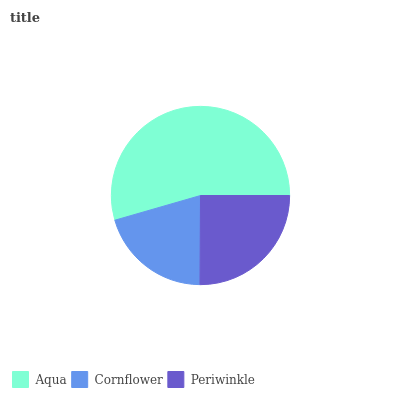Is Cornflower the minimum?
Answer yes or no. Yes. Is Aqua the maximum?
Answer yes or no. Yes. Is Periwinkle the minimum?
Answer yes or no. No. Is Periwinkle the maximum?
Answer yes or no. No. Is Periwinkle greater than Cornflower?
Answer yes or no. Yes. Is Cornflower less than Periwinkle?
Answer yes or no. Yes. Is Cornflower greater than Periwinkle?
Answer yes or no. No. Is Periwinkle less than Cornflower?
Answer yes or no. No. Is Periwinkle the high median?
Answer yes or no. Yes. Is Periwinkle the low median?
Answer yes or no. Yes. Is Cornflower the high median?
Answer yes or no. No. Is Cornflower the low median?
Answer yes or no. No. 